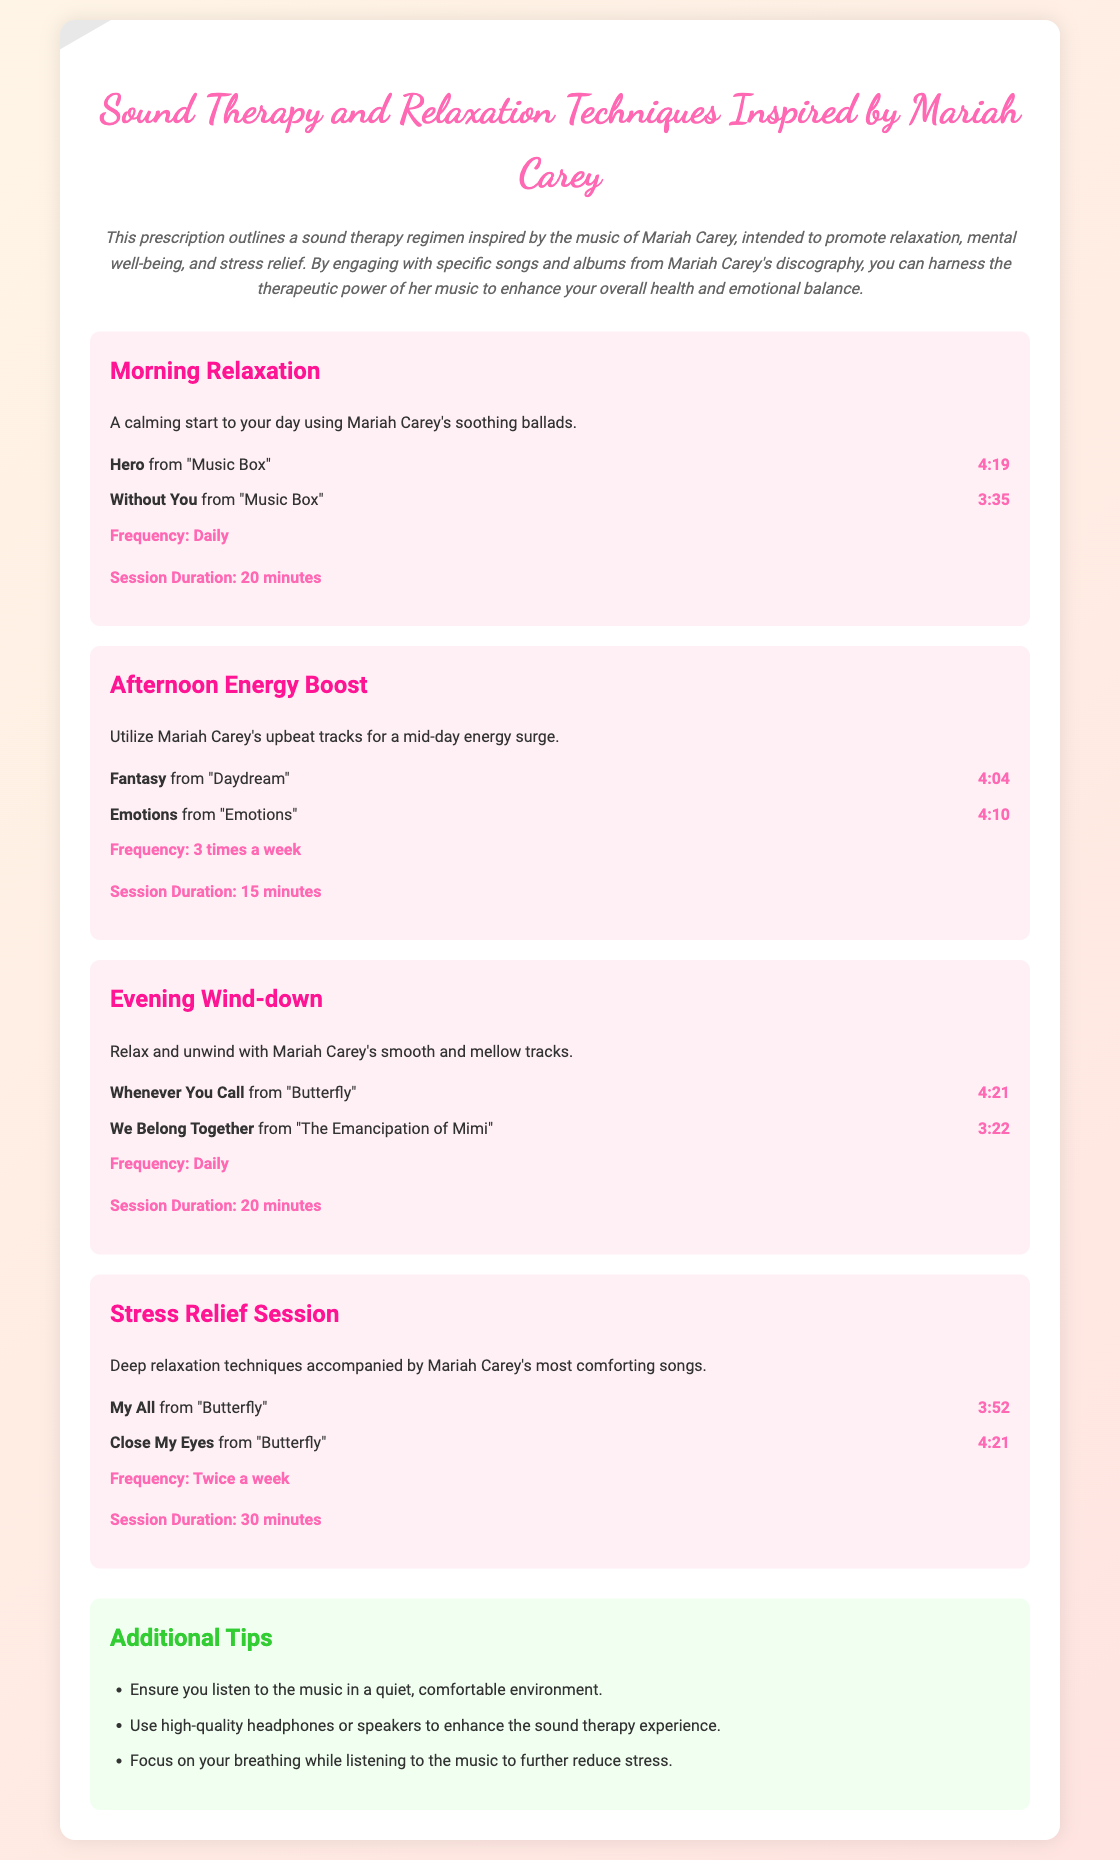What is the title of the document? The title of the document is the main header that identifies its content.
Answer: Sound Therapy and Relaxation Techniques Inspired by Mariah Carey How long is the song "Hero" from "Music Box"? The duration of "Hero" is specified alongside its title in the document.
Answer: 4:19 What is the frequency of the Morning Relaxation session? The frequency is mentioned in the section detailing the Morning Relaxation session.
Answer: Daily Which song is included in the Evening Wind-down session? The document lists specific songs for each session, including the Evening Wind-down.
Answer: Whenever You Call How many times a week should the Stress Relief Session be performed? The frequency of the Stress Relief Session is clearly stated in its section.
Answer: Twice a week What are the two types of sessions categorized in this document? The document specifies categories of therapeutic sessions that utilize Mariah Carey's music.
Answer: Relaxation and Stress Relief What is the total duration of the Afternoon Energy Boost session? The total duration is provided as part of the session details for the Afternoon Energy Boost.
Answer: 15 minutes What is one additional tip for enhancing the sound therapy experience? The document mentions various tips to improve the sound therapy experience with Mariah Carey's music.
Answer: Listen in a quiet, comfortable environment 